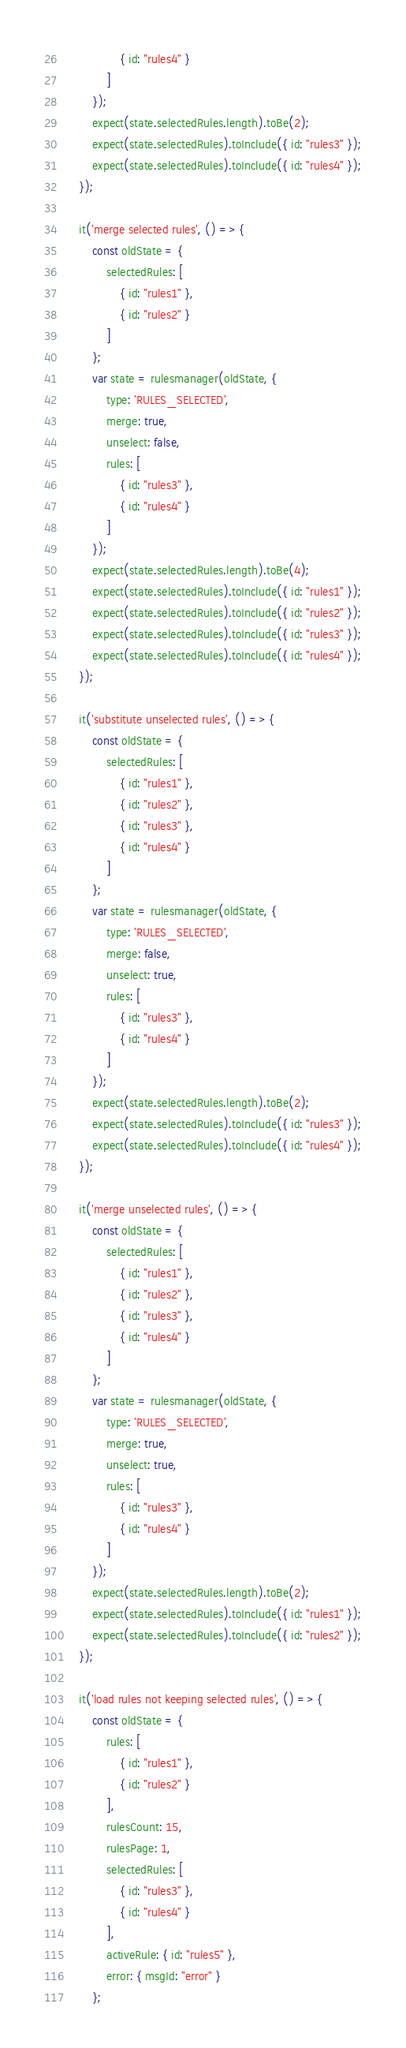<code> <loc_0><loc_0><loc_500><loc_500><_JavaScript_>                { id: "rules4" }
            ]
        });
        expect(state.selectedRules.length).toBe(2);
        expect(state.selectedRules).toInclude({ id: "rules3" });
        expect(state.selectedRules).toInclude({ id: "rules4" });
    });

    it('merge selected rules', () => {
        const oldState = {
            selectedRules: [
                { id: "rules1" },
                { id: "rules2" }
            ]
        };
        var state = rulesmanager(oldState, {
            type: 'RULES_SELECTED',
            merge: true,
            unselect: false,
            rules: [
                { id: "rules3" },
                { id: "rules4" }
            ]
        });
        expect(state.selectedRules.length).toBe(4);
        expect(state.selectedRules).toInclude({ id: "rules1" });
        expect(state.selectedRules).toInclude({ id: "rules2" });
        expect(state.selectedRules).toInclude({ id: "rules3" });
        expect(state.selectedRules).toInclude({ id: "rules4" });
    });

    it('substitute unselected rules', () => {
        const oldState = {
            selectedRules: [
                { id: "rules1" },
                { id: "rules2" },
                { id: "rules3" },
                { id: "rules4" }
            ]
        };
        var state = rulesmanager(oldState, {
            type: 'RULES_SELECTED',
            merge: false,
            unselect: true,
            rules: [
                { id: "rules3" },
                { id: "rules4" }
            ]
        });
        expect(state.selectedRules.length).toBe(2);
        expect(state.selectedRules).toInclude({ id: "rules3" });
        expect(state.selectedRules).toInclude({ id: "rules4" });
    });

    it('merge unselected rules', () => {
        const oldState = {
            selectedRules: [
                { id: "rules1" },
                { id: "rules2" },
                { id: "rules3" },
                { id: "rules4" }
            ]
        };
        var state = rulesmanager(oldState, {
            type: 'RULES_SELECTED',
            merge: true,
            unselect: true,
            rules: [
                { id: "rules3" },
                { id: "rules4" }
            ]
        });
        expect(state.selectedRules.length).toBe(2);
        expect(state.selectedRules).toInclude({ id: "rules1" });
        expect(state.selectedRules).toInclude({ id: "rules2" });
    });

    it('load rules not keeping selected rules', () => {
        const oldState = {
            rules: [
                { id: "rules1" },
                { id: "rules2" }
            ],
            rulesCount: 15,
            rulesPage: 1,
            selectedRules: [
                { id: "rules3" },
                { id: "rules4" }
            ],
            activeRule: { id: "rules5" },
            error: { msgId: "error" }
        };</code> 